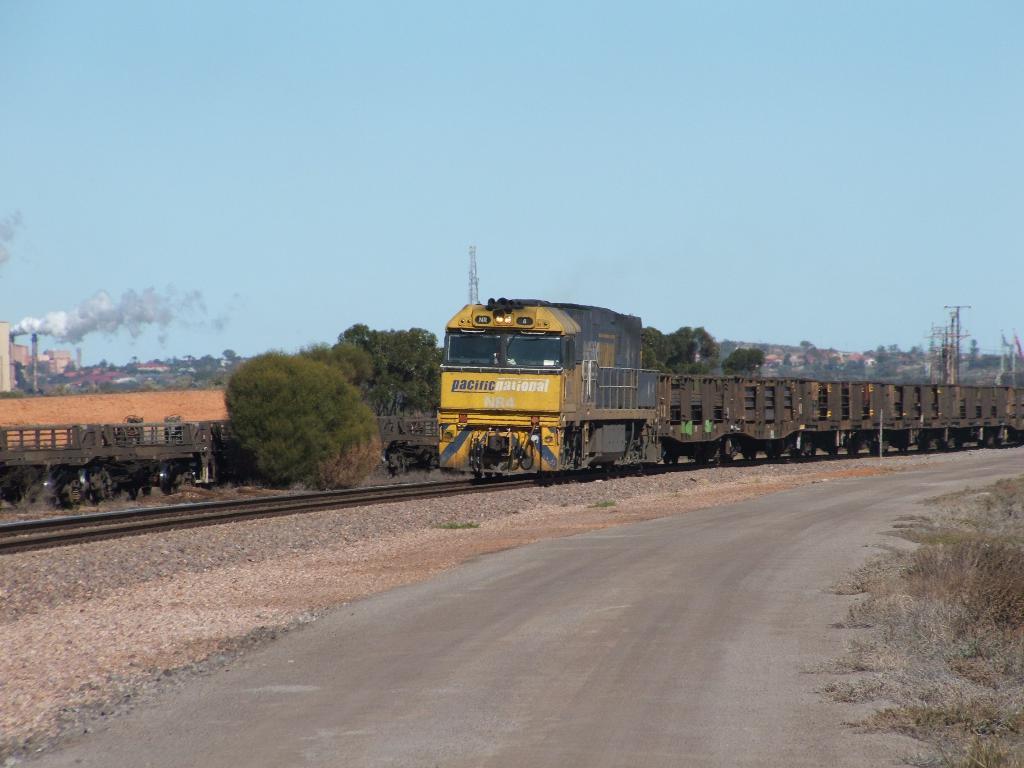Please provide a concise description of this image. In this image there are two trains on the railway track. In front of the image there is a road. Beside the road there's grass on the surface. In the background of the image there are trees, buildings, towers and sky. 